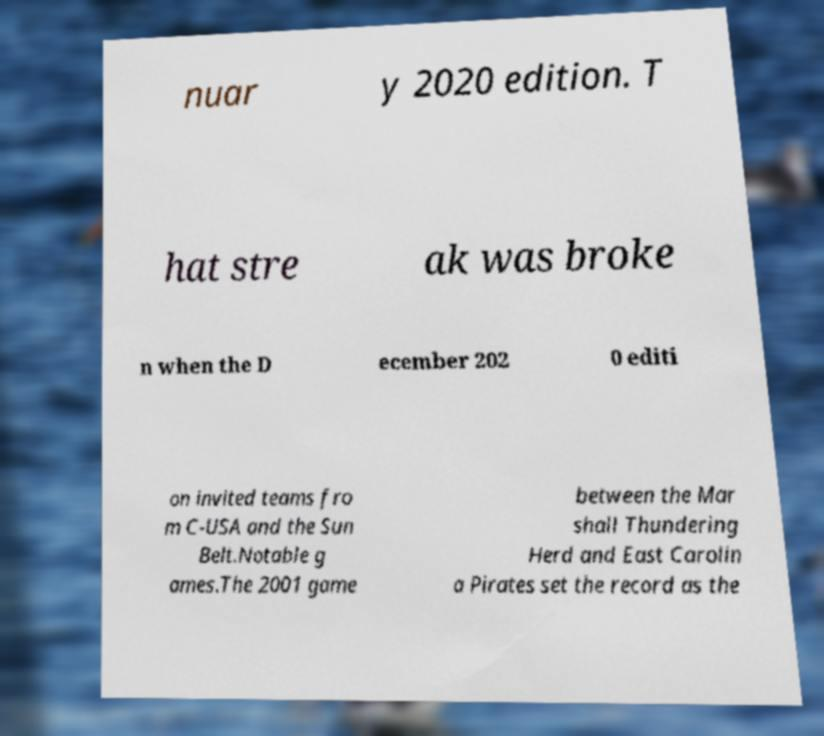Can you read and provide the text displayed in the image?This photo seems to have some interesting text. Can you extract and type it out for me? nuar y 2020 edition. T hat stre ak was broke n when the D ecember 202 0 editi on invited teams fro m C-USA and the Sun Belt.Notable g ames.The 2001 game between the Mar shall Thundering Herd and East Carolin a Pirates set the record as the 